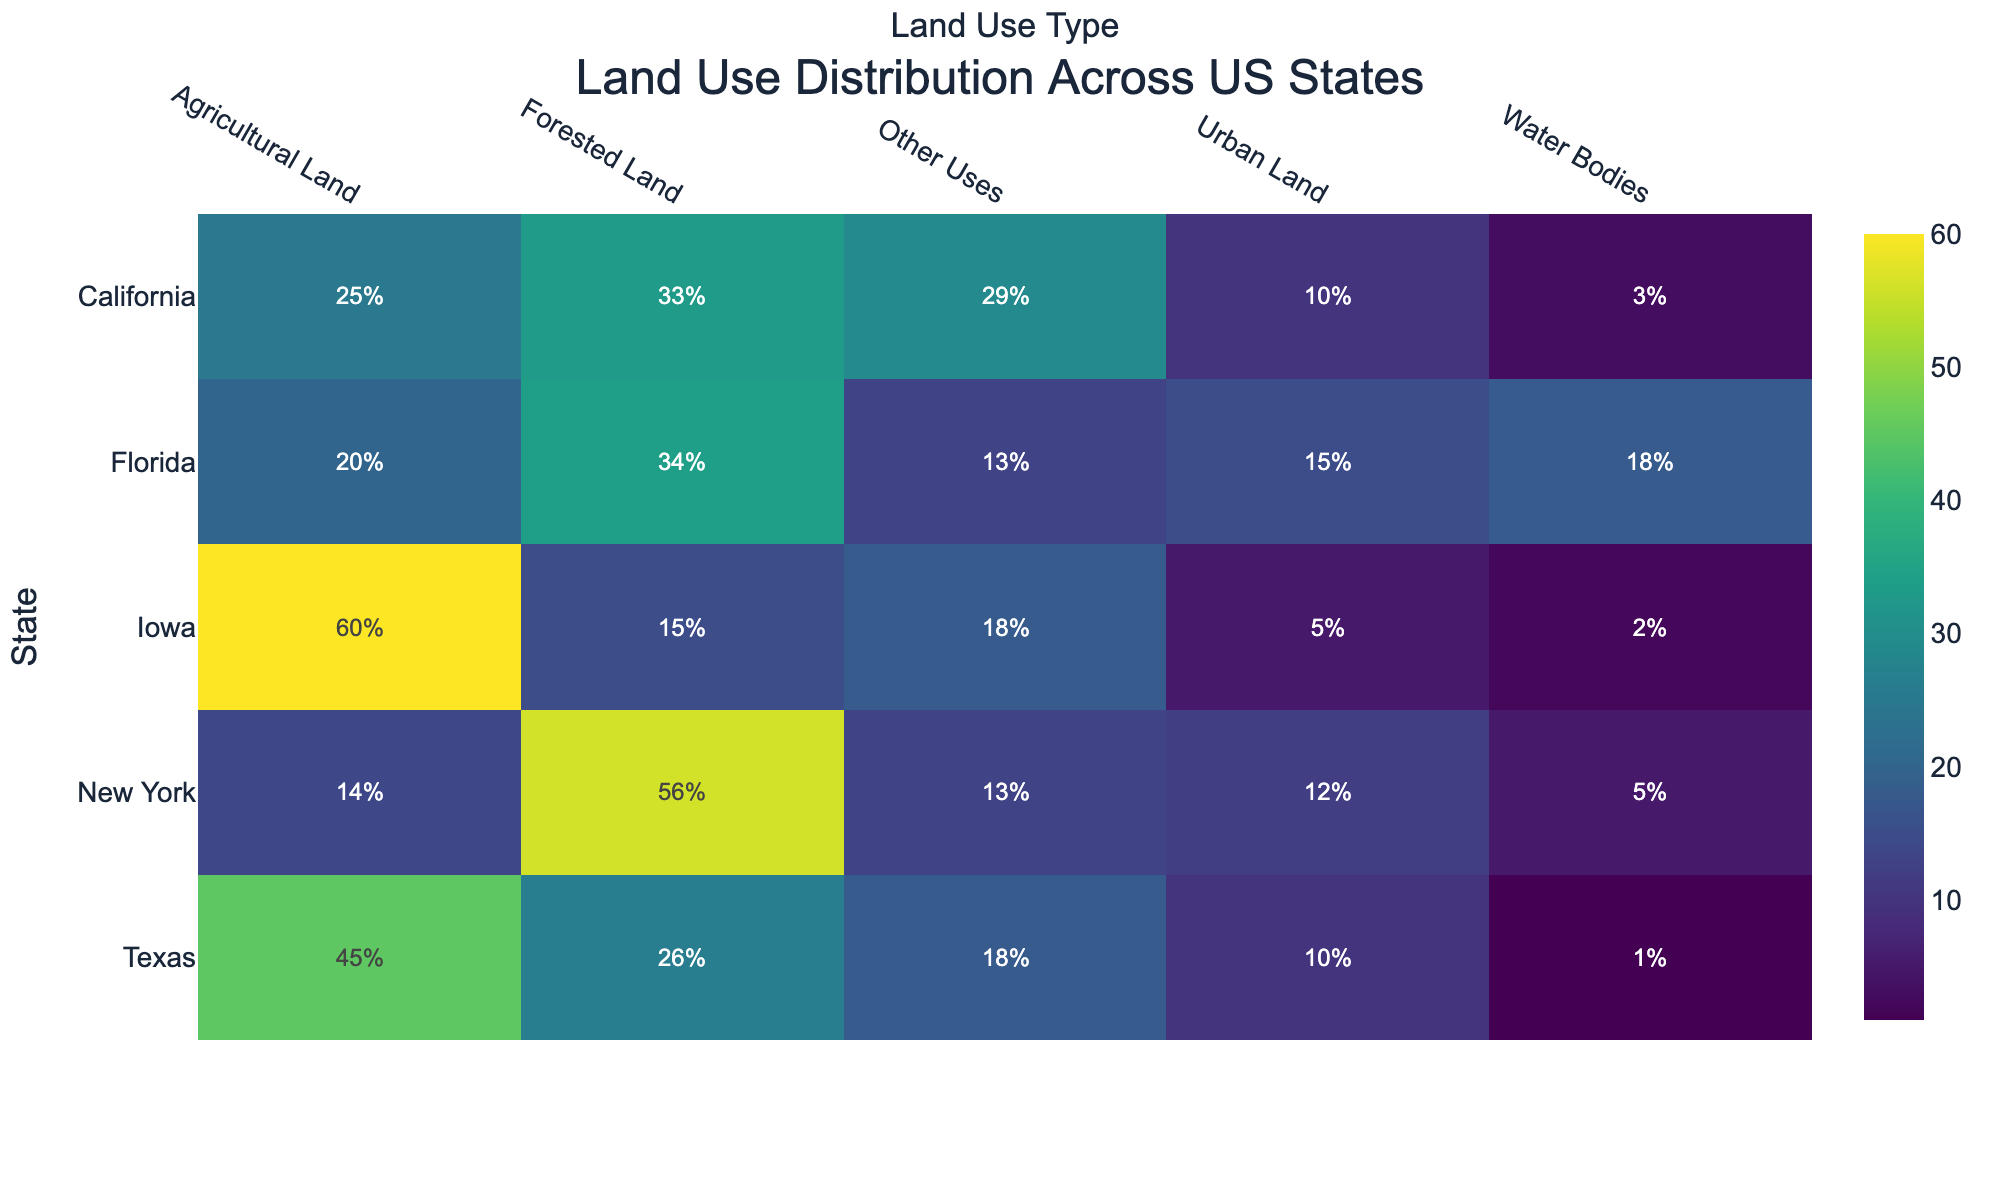What's the title of the heatmap? The title is located at the top center of the heatmap. It is displayed prominently in a larger font.
Answer: Land Use Distribution Across US States Which state has the highest percentage of forested land? Look for the highest value in the 'Forested Land' column. New York has the highest percentage with 56%.
Answer: New York What is the percentage of urban land in Iowa? Look in the 'Urban Land' column and find the value corresponding to Iowa. The percentage is displayed as 5.
Answer: 5% What's the average percentage of water bodies in the listed states? Add the percentages for Water Bodies across all states (3 for CA, 1 for TX, 2 for IA, 18 for FL, 5 for NY). The sum is 29. Divide 29 by the number of states (5). 29/5 = 5.8
Answer: 5.8% Which state has a higher percentage of agricultural land, California or Texas? Compare the values in the 'Agricultural Land' column for California (25%) and Texas (45%). Texas has a higher percentage.
Answer: Texas What is the combined percentage of 'Urban Land' and 'Other Uses' in California? Add the percentages for 'Urban Land' (10%) and 'Other Uses' (29%) in California: 10 + 29 = 39.
Answer: 39% Which state has the least percentage of water bodies? The smallest value in the 'Water Bodies' column is 1, which corresponds to Texas.
Answer: Texas Which land use type has the most variation across the states? Assess the range of values for each land use type. 'Agricultural Land' ranges from 14% to 60%, the widest range of percentage values.
Answer: Agricultural Land In which land use category is Florida leading in percentage compared to the other states? Identify the highest value in each column. For 'Water Bodies', Florida has the highest value with 18%.
Answer: Water Bodies What is the total percentage of forested land across all the states? Sum the percentages for 'Forested Land' across all states (CA: 33%, TX: 26%, IA: 15%, FL: 34%, NY: 56%). 33 + 26 + 15 + 34 + 56 = 164.
Answer: 164% 